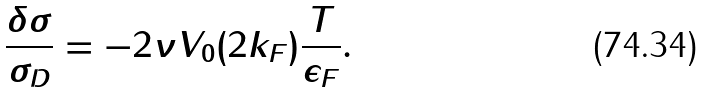Convert formula to latex. <formula><loc_0><loc_0><loc_500><loc_500>\frac { \delta \sigma } { \sigma _ { D } } = - 2 \nu V _ { 0 } ( 2 k _ { F } ) \frac { T } { \epsilon _ { F } } .</formula> 